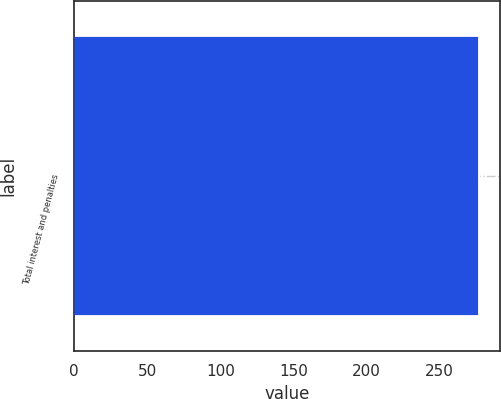Convert chart to OTSL. <chart><loc_0><loc_0><loc_500><loc_500><bar_chart><fcel>Total interest and penalties<nl><fcel>277<nl></chart> 